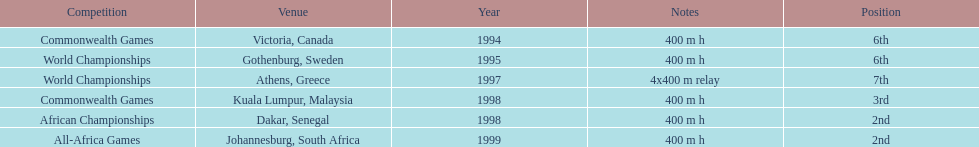What is the total number of competitions on this chart? 6. 